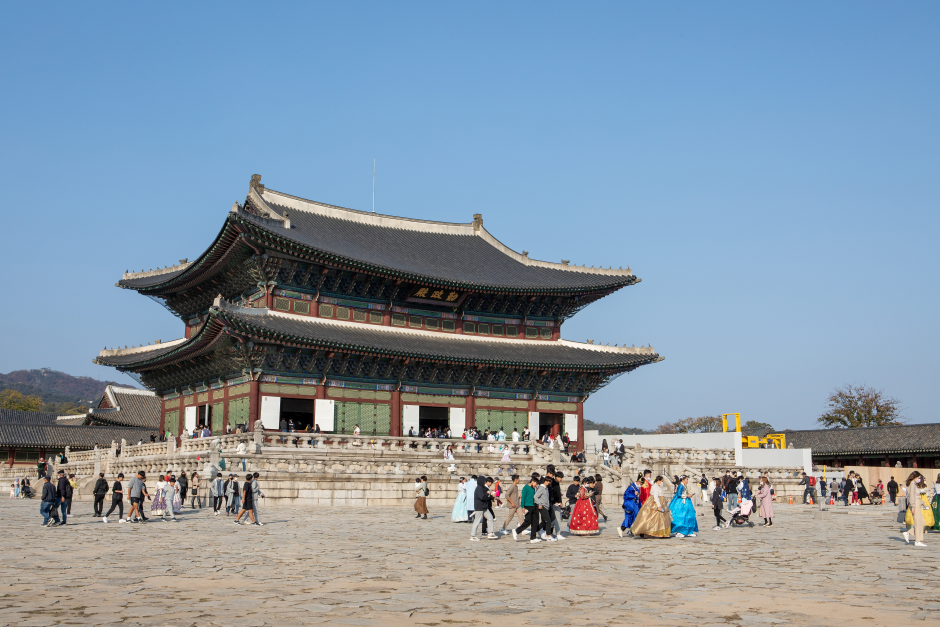Imagine a fantasy scenario involving this palace. What would it look like? In a fantastical scenario, Gyeongbokgung Palace transforms into a magical castle, shimmering with enchanted lights as dusk falls. The courtyard is filled with mythical creatures like dragons and phoenixes, coexisting with humans. The palace itself is alive with magic, its walls whispering ancient secrets. At night, the palace comes alive with a grand festival, where guardians of the realm perform spellbinding dances and music fills the air, creating an otherworldly atmosphere. The sky above is painted with glowing constellations, and a mystical full moon casts a silvery glow upon the palace, making it look ethereal and enchanting. What might a day in the life of a royal family member living here look like? A day in the life of a royal family member during the Joseon Dynasty would be meticulously planned and steeped in tradition. The day would begin early with morning rituals, including offerings and prayers at the palace's shrines. The royal family member would participate in various state affairs with the king, discussing important matters with court officials in the throne hall. Following the morning engagement, there would be a formal lunch with traditional Korean dishes meticulously prepared for the royal palate. In the afternoon, there might be lessons in Confucian classics, poetry, and music, essential for cultivating royal virtues. Free time could be spent strolling through the palace gardens or practicing archery. The evening would involve a ceremonial dinner, followed by cultural activities like watching traditional performances or engaging in discussions about philosophy and governance. The day concludes with a quiet, reflective routine in personal quarters, perhaps writing in a journal or reading before retiring to bed. 